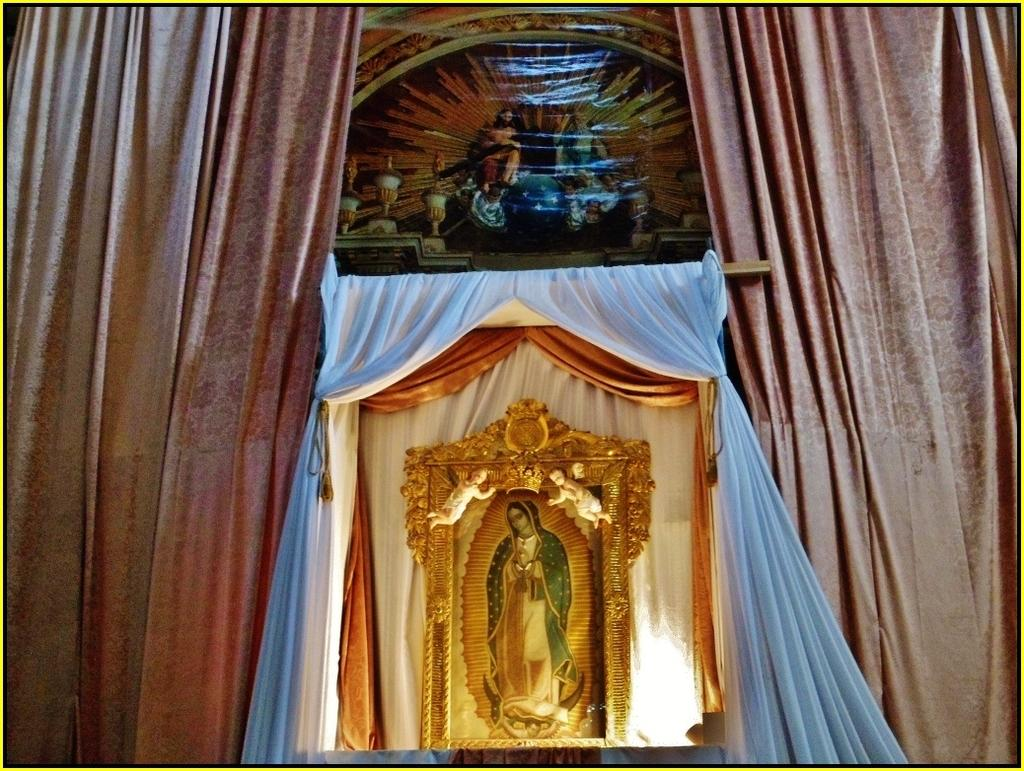What type of location might the image be taken in? The image might be taken in a church. What can be seen on the left side of the image? There are curtains on the left side of the image. What can be seen on the right side of the image? There are curtains on the right side of the image. What is the main subject in the middle of the image? There is a picture of the Mary goddess in the middle of the image. Can you hear the cough of the person sitting in the front row in the image? There is no person sitting in the front row in the image, and therefore no cough can be heard. 